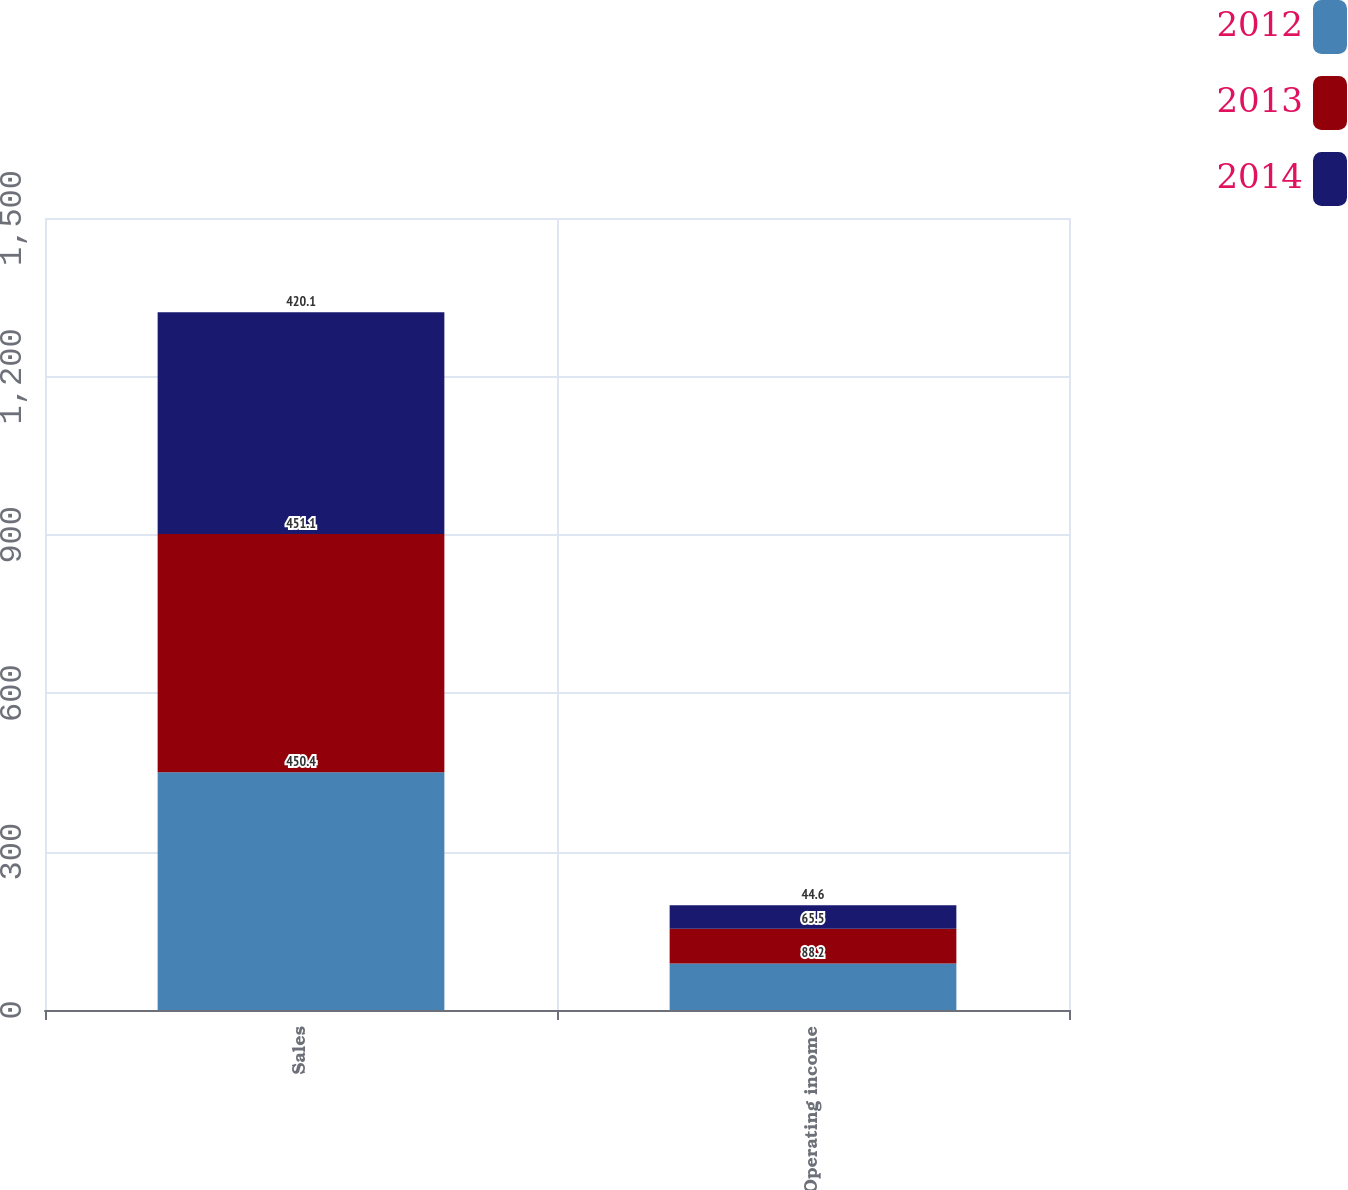Convert chart to OTSL. <chart><loc_0><loc_0><loc_500><loc_500><stacked_bar_chart><ecel><fcel>Sales<fcel>Operating income<nl><fcel>2012<fcel>450.4<fcel>88.2<nl><fcel>2013<fcel>451.1<fcel>65.5<nl><fcel>2014<fcel>420.1<fcel>44.6<nl></chart> 